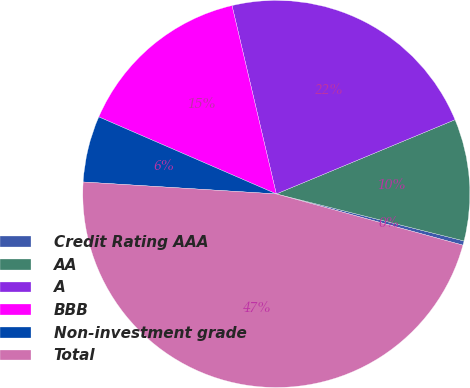Convert chart. <chart><loc_0><loc_0><loc_500><loc_500><pie_chart><fcel>Credit Rating AAA<fcel>AA<fcel>A<fcel>BBB<fcel>Non-investment grade<fcel>Total<nl><fcel>0.36%<fcel>10.17%<fcel>22.41%<fcel>14.81%<fcel>5.53%<fcel>46.72%<nl></chart> 